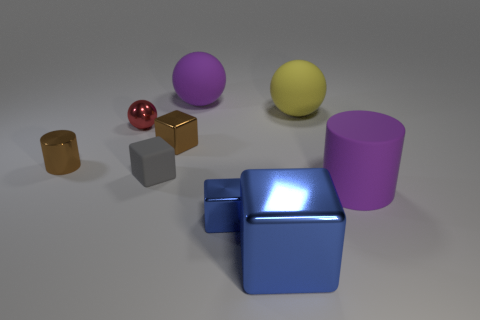Subtract all big rubber balls. How many balls are left? 1 Subtract all blue blocks. How many blocks are left? 2 Add 1 tiny red metal objects. How many objects exist? 10 Subtract all cubes. How many objects are left? 5 Subtract 1 cylinders. How many cylinders are left? 1 Add 1 cyan objects. How many cyan objects exist? 1 Subtract 0 brown balls. How many objects are left? 9 Subtract all blue cylinders. Subtract all brown balls. How many cylinders are left? 2 Subtract all green cubes. How many brown spheres are left? 0 Subtract all tiny spheres. Subtract all purple objects. How many objects are left? 6 